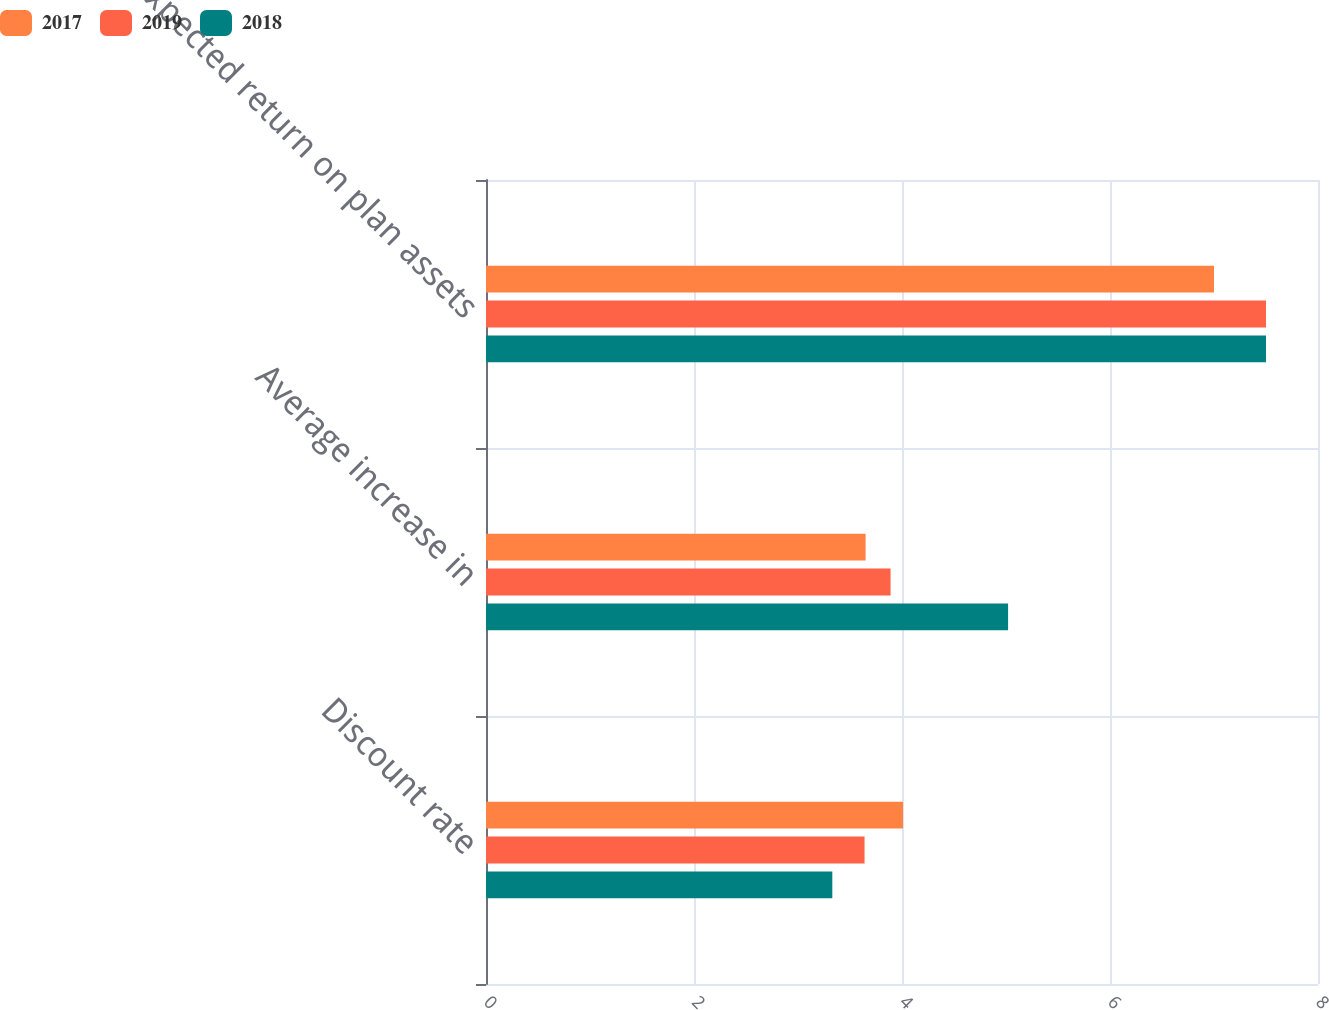Convert chart. <chart><loc_0><loc_0><loc_500><loc_500><stacked_bar_chart><ecel><fcel>Discount rate<fcel>Average increase in<fcel>Expected return on plan assets<nl><fcel>2017<fcel>4.01<fcel>3.65<fcel>7<nl><fcel>2019<fcel>3.64<fcel>3.89<fcel>7.5<nl><fcel>2018<fcel>3.33<fcel>5.02<fcel>7.5<nl></chart> 